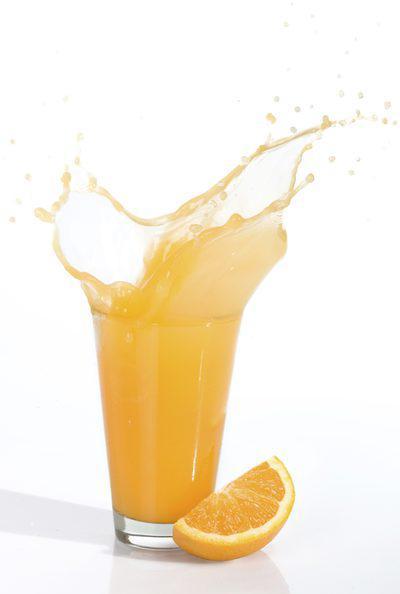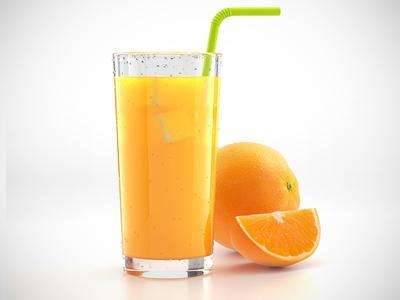The first image is the image on the left, the second image is the image on the right. Assess this claim about the two images: "At least one of the oranges still has its stem and leaves attached to it.". Correct or not? Answer yes or no. No. 